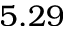<formula> <loc_0><loc_0><loc_500><loc_500>5 . 2 9</formula> 